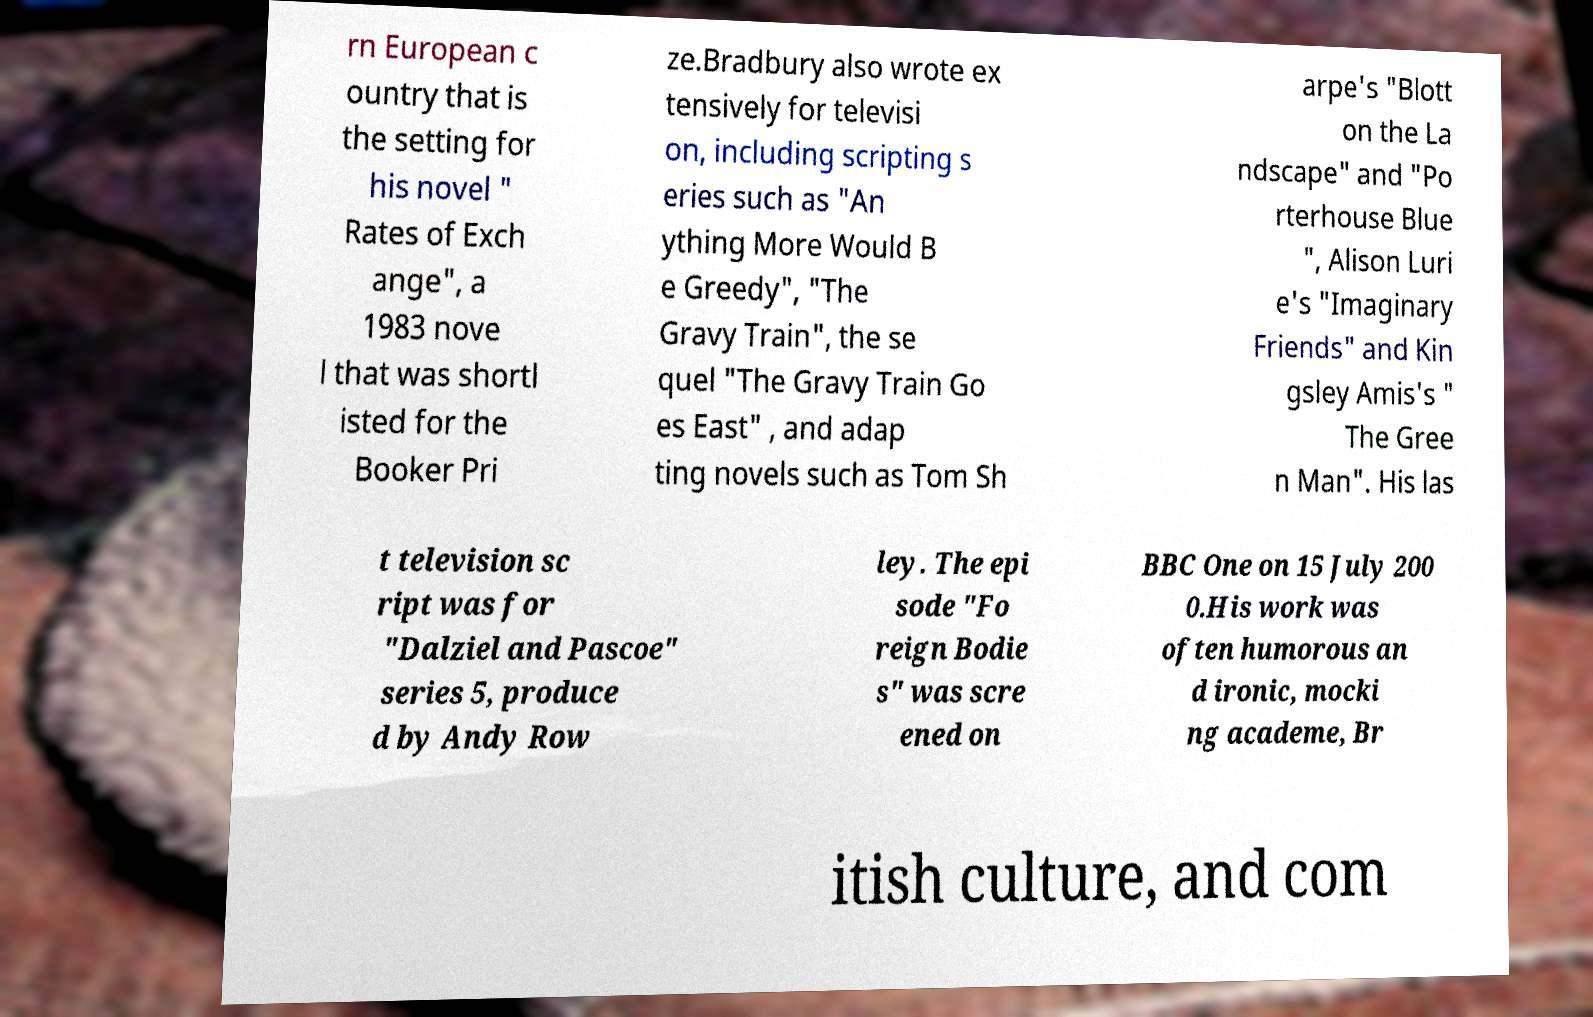Please read and relay the text visible in this image. What does it say? rn European c ountry that is the setting for his novel " Rates of Exch ange", a 1983 nove l that was shortl isted for the Booker Pri ze.Bradbury also wrote ex tensively for televisi on, including scripting s eries such as "An ything More Would B e Greedy", "The Gravy Train", the se quel "The Gravy Train Go es East" , and adap ting novels such as Tom Sh arpe's "Blott on the La ndscape" and "Po rterhouse Blue ", Alison Luri e's "Imaginary Friends" and Kin gsley Amis's " The Gree n Man". His las t television sc ript was for "Dalziel and Pascoe" series 5, produce d by Andy Row ley. The epi sode "Fo reign Bodie s" was scre ened on BBC One on 15 July 200 0.His work was often humorous an d ironic, mocki ng academe, Br itish culture, and com 